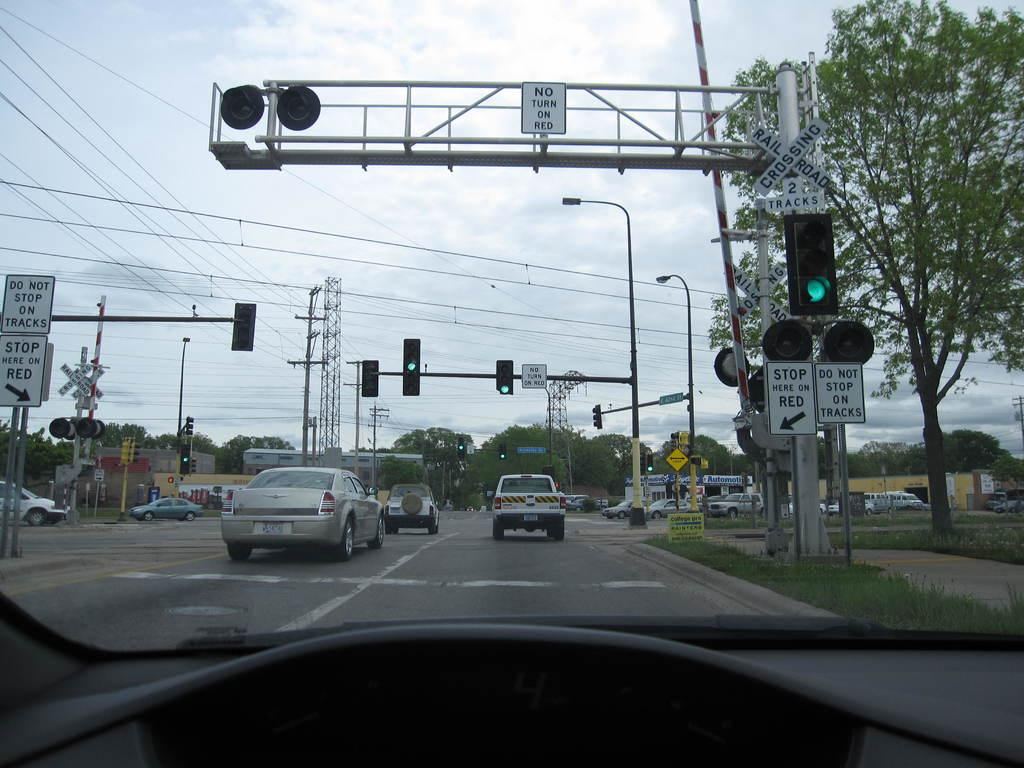<image>
Provide a brief description of the given image. a white sign says no turn on red outside 